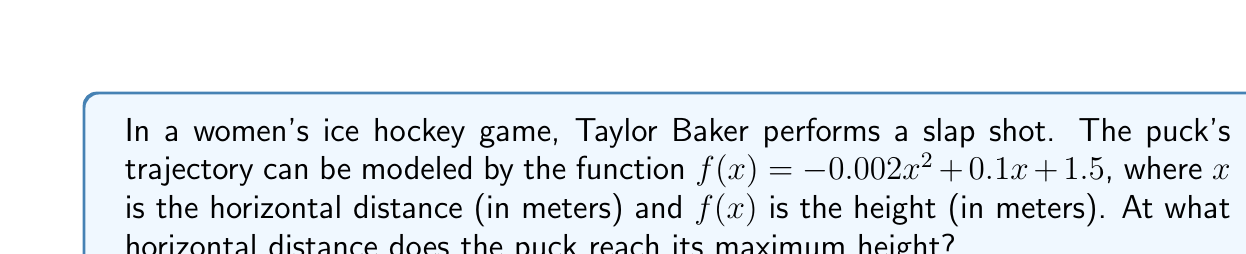Provide a solution to this math problem. To find the maximum height of the puck's trajectory, we need to follow these steps:

1) The function $f(x) = -0.002x^2 + 0.1x + 1.5$ is a quadratic function, which forms a parabola.

2) The maximum point of a parabola occurs at the vertex. For a parabola opening downward (negative coefficient of $x^2$), this is the highest point.

3) To find the x-coordinate of the vertex, we use the formula: $x = -\frac{b}{2a}$, where $a$ and $b$ are the coefficients of $x^2$ and $x$ respectively in the quadratic equation $ax^2 + bx + c$.

4) In this case, $a = -0.002$ and $b = 0.1$

5) Substituting into the formula:

   $x = -\frac{0.1}{2(-0.002)} = -\frac{0.1}{-0.004} = 25$

6) Therefore, the puck reaches its maximum height when $x = 25$ meters.

[asy]
import graph;
size(200,150);
real f(real x) {return -0.002x^2 + 0.1x + 1.5;}
draw(graph(f,0,50),blue);
dot((25,f(25)),red);
label("(25, 2.75)",(25,f(25)),NE);
xaxis("x (meters)",arrow=Arrow);
yaxis("y (meters)",arrow=Arrow);
[/asy]
Answer: 25 meters 